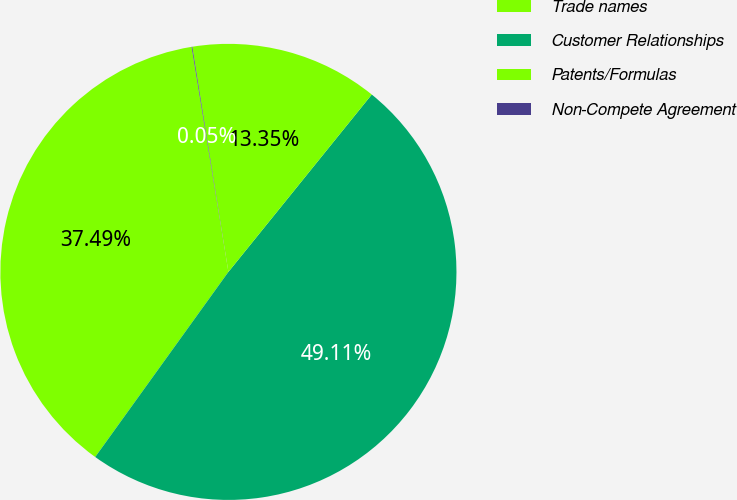Convert chart to OTSL. <chart><loc_0><loc_0><loc_500><loc_500><pie_chart><fcel>Trade names<fcel>Customer Relationships<fcel>Patents/Formulas<fcel>Non-Compete Agreement<nl><fcel>37.49%<fcel>49.11%<fcel>13.35%<fcel>0.05%<nl></chart> 